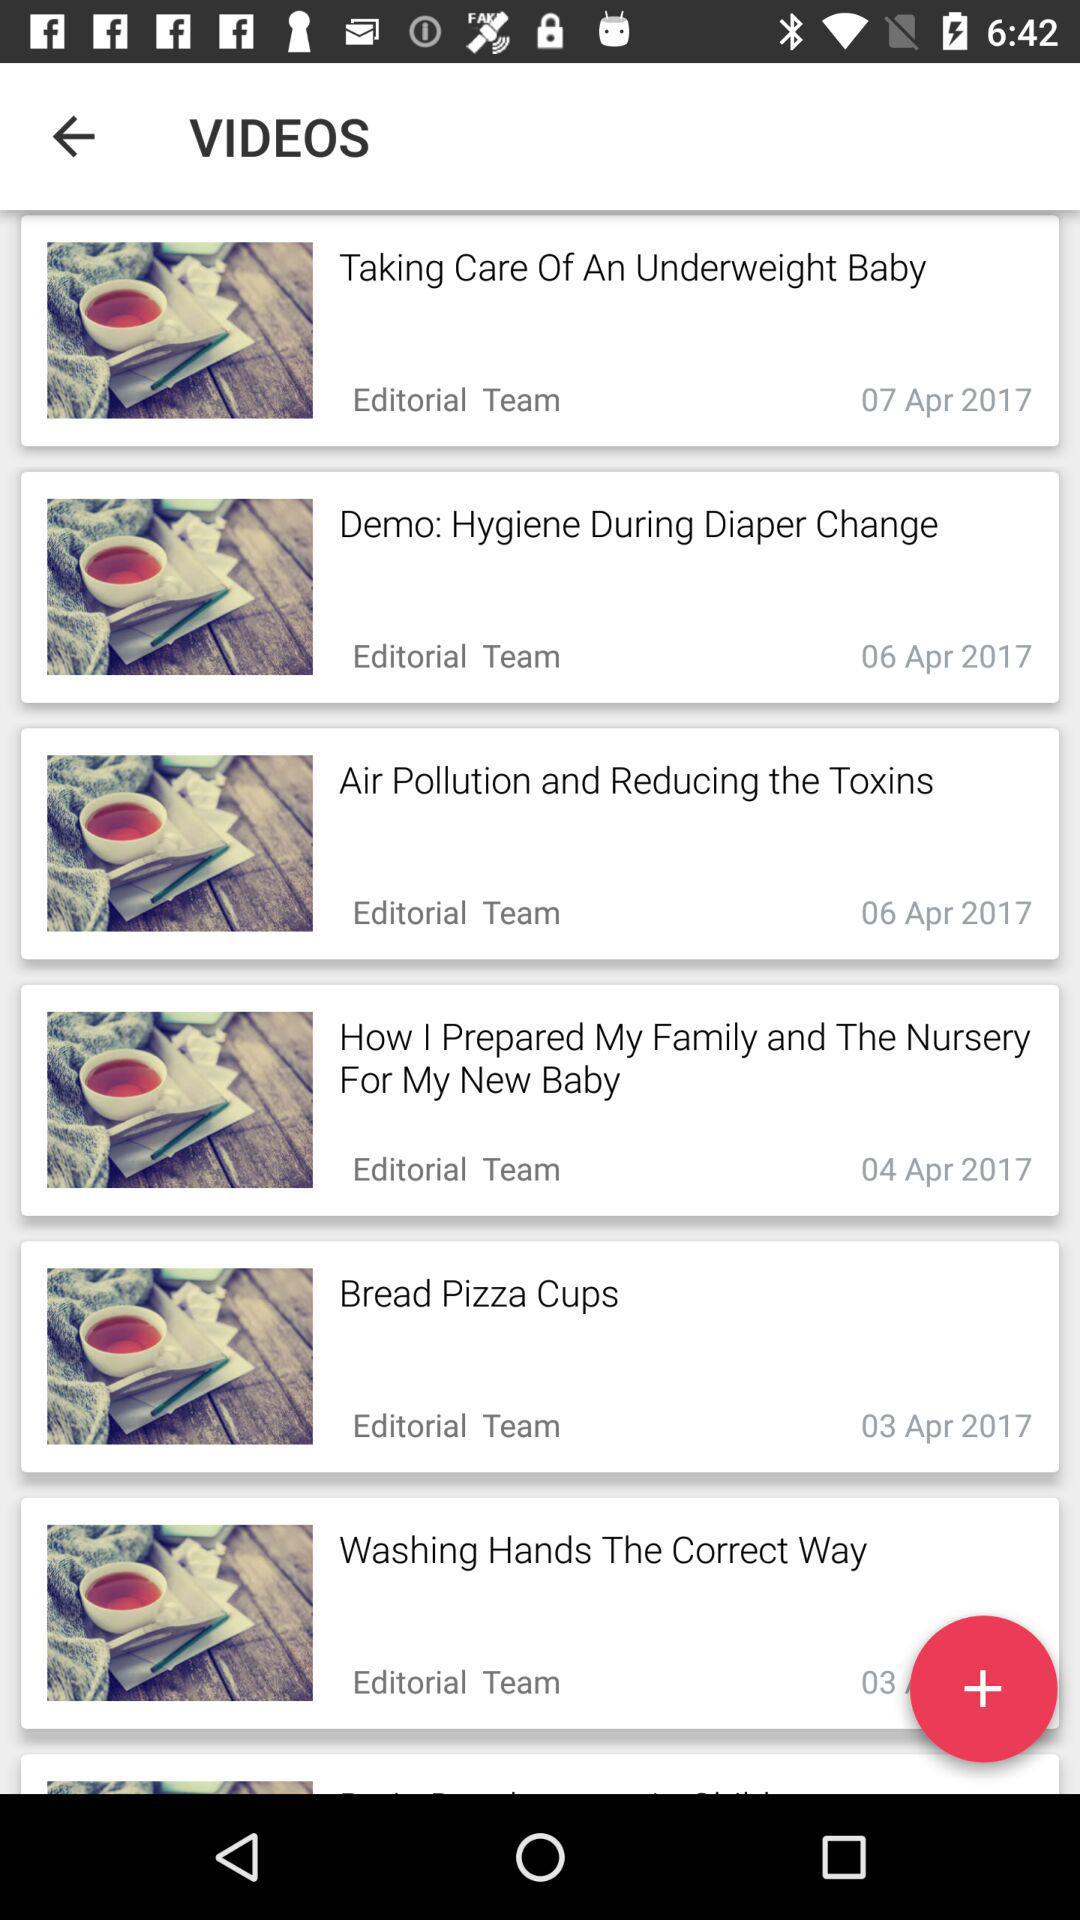What is the published date of the "Bread Pizza Cup" video? The posted date is April 3, 2017. 